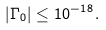Convert formula to latex. <formula><loc_0><loc_0><loc_500><loc_500>| \Gamma _ { 0 } | \leq 1 0 ^ { - 1 8 } .</formula> 